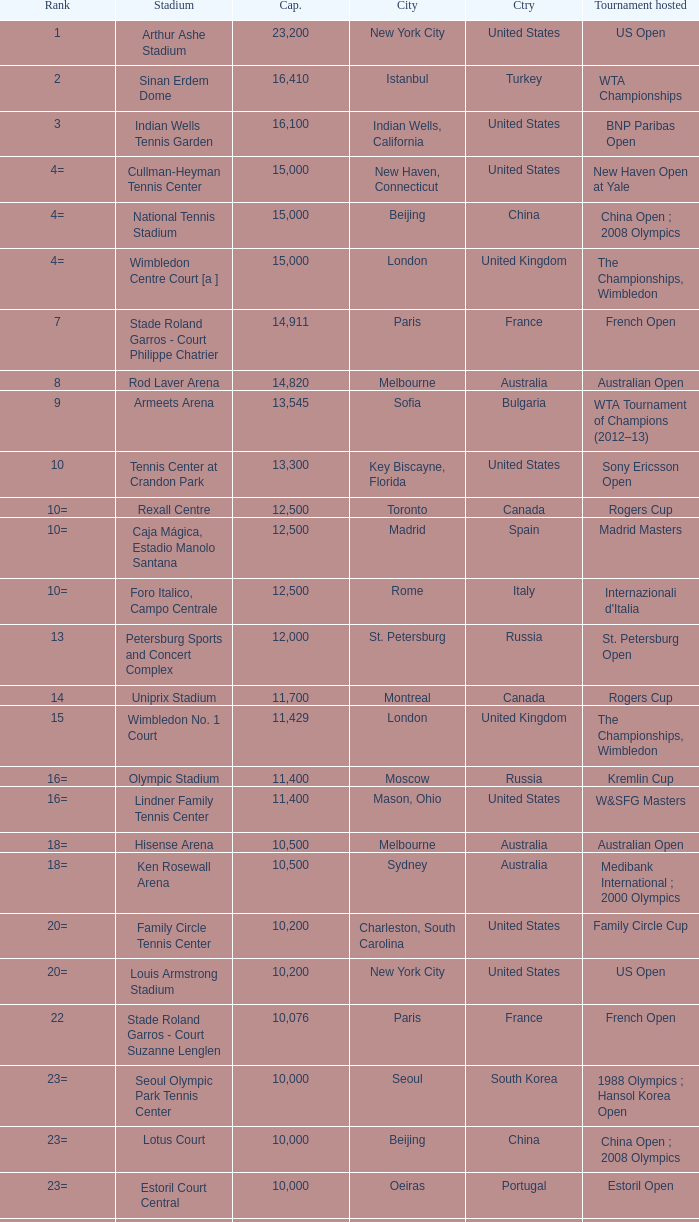What country has grandstand stadium as the stadium? United States. 